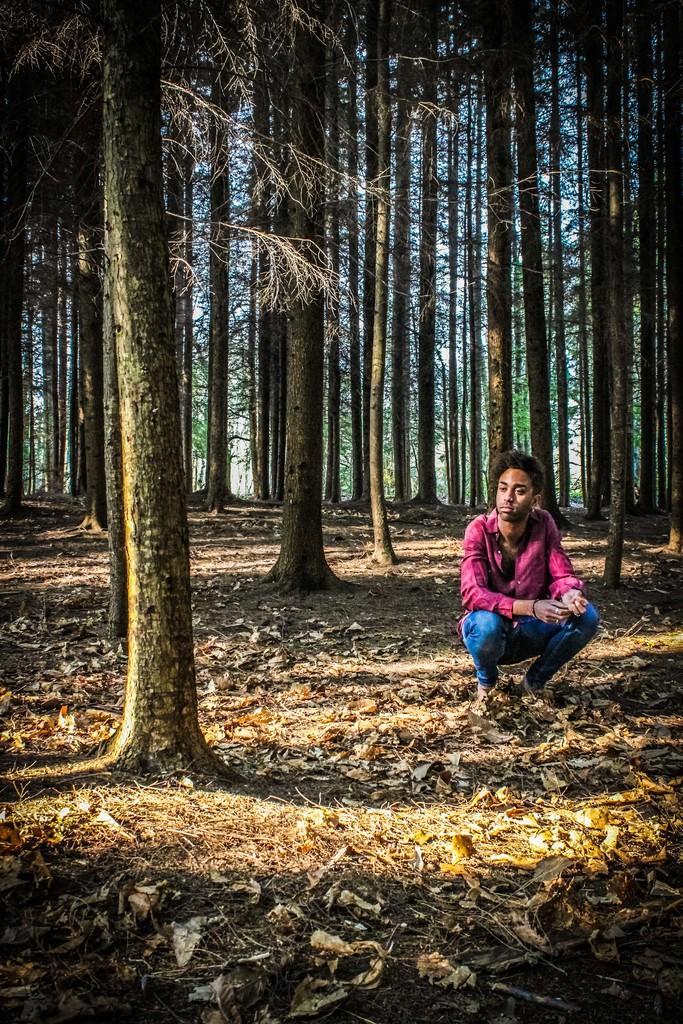How would you summarize this image in a sentence or two? In foreground of the picture there are dry leaves, grass, trees and a person. In the background there are trees. 